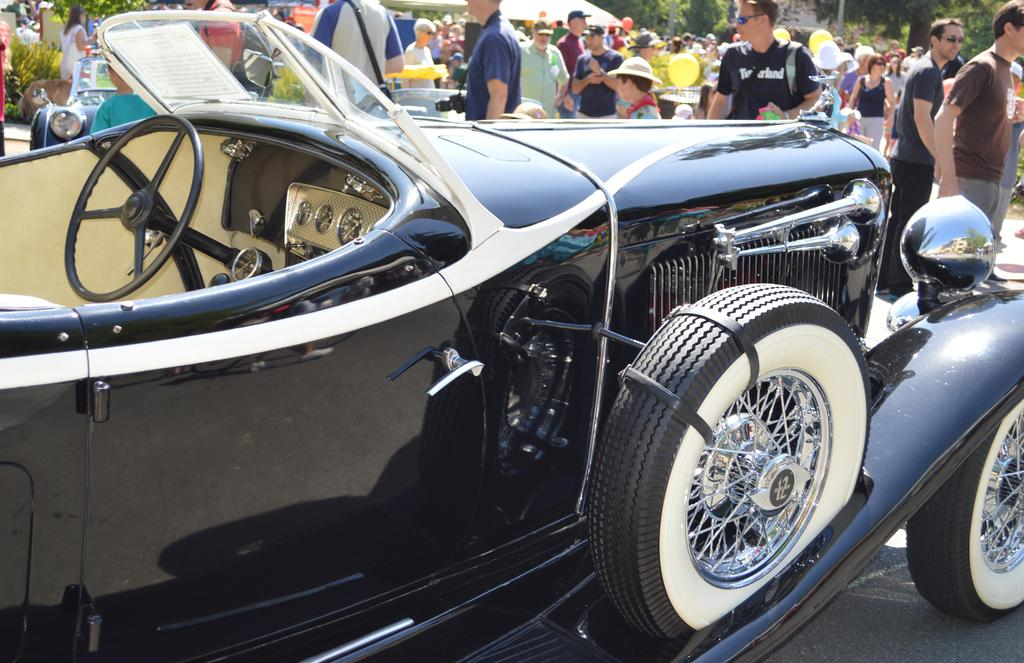What type of car is in the image? There is a black vintage car in the image. Where is the car located in the image? The car is parked in the front. What else can be seen in the image besides the car? There is a group of men and women in the image. What are the people in the image doing? The group is standing in a car exhibition rally. What type of story is being told by the cow in the image? There is no cow present in the image, so no story can be told by a cow. Where is the drawer located in the image? There is no drawer present in the image. 